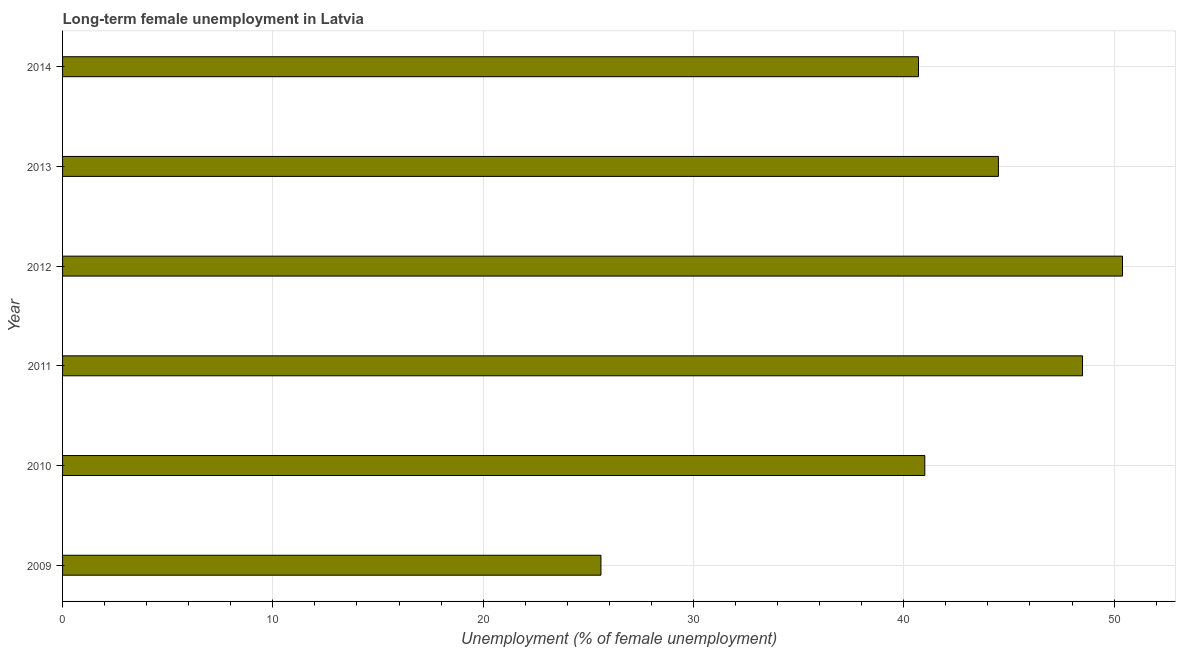Does the graph contain any zero values?
Your answer should be very brief. No. What is the title of the graph?
Make the answer very short. Long-term female unemployment in Latvia. What is the label or title of the X-axis?
Ensure brevity in your answer.  Unemployment (% of female unemployment). What is the label or title of the Y-axis?
Keep it short and to the point. Year. What is the long-term female unemployment in 2009?
Offer a terse response. 25.6. Across all years, what is the maximum long-term female unemployment?
Provide a succinct answer. 50.4. Across all years, what is the minimum long-term female unemployment?
Give a very brief answer. 25.6. In which year was the long-term female unemployment maximum?
Your response must be concise. 2012. In which year was the long-term female unemployment minimum?
Give a very brief answer. 2009. What is the sum of the long-term female unemployment?
Give a very brief answer. 250.7. What is the average long-term female unemployment per year?
Ensure brevity in your answer.  41.78. What is the median long-term female unemployment?
Ensure brevity in your answer.  42.75. Do a majority of the years between 2009 and 2013 (inclusive) have long-term female unemployment greater than 36 %?
Offer a terse response. Yes. What is the ratio of the long-term female unemployment in 2010 to that in 2013?
Your response must be concise. 0.92. Is the long-term female unemployment in 2012 less than that in 2014?
Offer a terse response. No. Is the difference between the long-term female unemployment in 2009 and 2011 greater than the difference between any two years?
Your response must be concise. No. What is the difference between the highest and the lowest long-term female unemployment?
Provide a short and direct response. 24.8. How many bars are there?
Make the answer very short. 6. What is the difference between two consecutive major ticks on the X-axis?
Your answer should be compact. 10. What is the Unemployment (% of female unemployment) of 2009?
Provide a short and direct response. 25.6. What is the Unemployment (% of female unemployment) of 2010?
Provide a succinct answer. 41. What is the Unemployment (% of female unemployment) of 2011?
Your answer should be very brief. 48.5. What is the Unemployment (% of female unemployment) in 2012?
Make the answer very short. 50.4. What is the Unemployment (% of female unemployment) of 2013?
Provide a succinct answer. 44.5. What is the Unemployment (% of female unemployment) of 2014?
Make the answer very short. 40.7. What is the difference between the Unemployment (% of female unemployment) in 2009 and 2010?
Give a very brief answer. -15.4. What is the difference between the Unemployment (% of female unemployment) in 2009 and 2011?
Your answer should be compact. -22.9. What is the difference between the Unemployment (% of female unemployment) in 2009 and 2012?
Make the answer very short. -24.8. What is the difference between the Unemployment (% of female unemployment) in 2009 and 2013?
Offer a very short reply. -18.9. What is the difference between the Unemployment (% of female unemployment) in 2009 and 2014?
Make the answer very short. -15.1. What is the difference between the Unemployment (% of female unemployment) in 2010 and 2011?
Ensure brevity in your answer.  -7.5. What is the difference between the Unemployment (% of female unemployment) in 2010 and 2013?
Provide a short and direct response. -3.5. What is the difference between the Unemployment (% of female unemployment) in 2010 and 2014?
Offer a terse response. 0.3. What is the difference between the Unemployment (% of female unemployment) in 2011 and 2012?
Make the answer very short. -1.9. What is the difference between the Unemployment (% of female unemployment) in 2011 and 2014?
Your answer should be compact. 7.8. What is the difference between the Unemployment (% of female unemployment) in 2012 and 2014?
Make the answer very short. 9.7. What is the ratio of the Unemployment (% of female unemployment) in 2009 to that in 2010?
Give a very brief answer. 0.62. What is the ratio of the Unemployment (% of female unemployment) in 2009 to that in 2011?
Give a very brief answer. 0.53. What is the ratio of the Unemployment (% of female unemployment) in 2009 to that in 2012?
Provide a short and direct response. 0.51. What is the ratio of the Unemployment (% of female unemployment) in 2009 to that in 2013?
Your answer should be very brief. 0.57. What is the ratio of the Unemployment (% of female unemployment) in 2009 to that in 2014?
Ensure brevity in your answer.  0.63. What is the ratio of the Unemployment (% of female unemployment) in 2010 to that in 2011?
Ensure brevity in your answer.  0.84. What is the ratio of the Unemployment (% of female unemployment) in 2010 to that in 2012?
Offer a very short reply. 0.81. What is the ratio of the Unemployment (% of female unemployment) in 2010 to that in 2013?
Offer a very short reply. 0.92. What is the ratio of the Unemployment (% of female unemployment) in 2010 to that in 2014?
Provide a succinct answer. 1.01. What is the ratio of the Unemployment (% of female unemployment) in 2011 to that in 2012?
Your answer should be compact. 0.96. What is the ratio of the Unemployment (% of female unemployment) in 2011 to that in 2013?
Make the answer very short. 1.09. What is the ratio of the Unemployment (% of female unemployment) in 2011 to that in 2014?
Your answer should be very brief. 1.19. What is the ratio of the Unemployment (% of female unemployment) in 2012 to that in 2013?
Your answer should be compact. 1.13. What is the ratio of the Unemployment (% of female unemployment) in 2012 to that in 2014?
Make the answer very short. 1.24. What is the ratio of the Unemployment (% of female unemployment) in 2013 to that in 2014?
Make the answer very short. 1.09. 